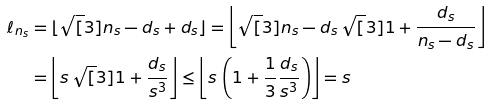Convert formula to latex. <formula><loc_0><loc_0><loc_500><loc_500>\ell _ { n _ { s } } & = \lfloor \sqrt { [ } 3 ] { n _ { s } - d _ { s } + d _ { s } } \rfloor = \left \lfloor \sqrt { [ } 3 ] { n _ { s } - d _ { s } } \, \sqrt { [ } 3 ] { 1 + \frac { d _ { s } } { n _ { s } - d _ { s } } } \right \rfloor \\ & = \left \lfloor s \, \sqrt { [ } 3 ] { 1 + \frac { d _ { s } } { s ^ { 3 } } } \right \rfloor \leq \left \lfloor s \, \left ( 1 + \frac { 1 } { 3 } \frac { d _ { s } } { s ^ { 3 } } \right ) \right \rfloor = s</formula> 